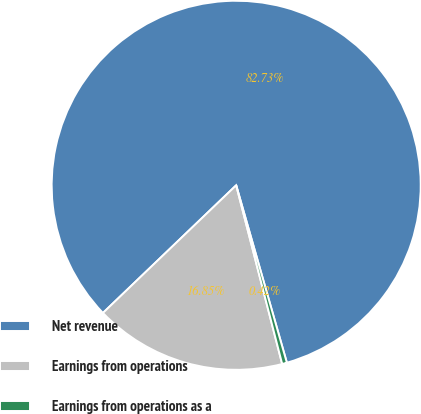<chart> <loc_0><loc_0><loc_500><loc_500><pie_chart><fcel>Net revenue<fcel>Earnings from operations<fcel>Earnings from operations as a<nl><fcel>82.73%<fcel>16.85%<fcel>0.42%<nl></chart> 